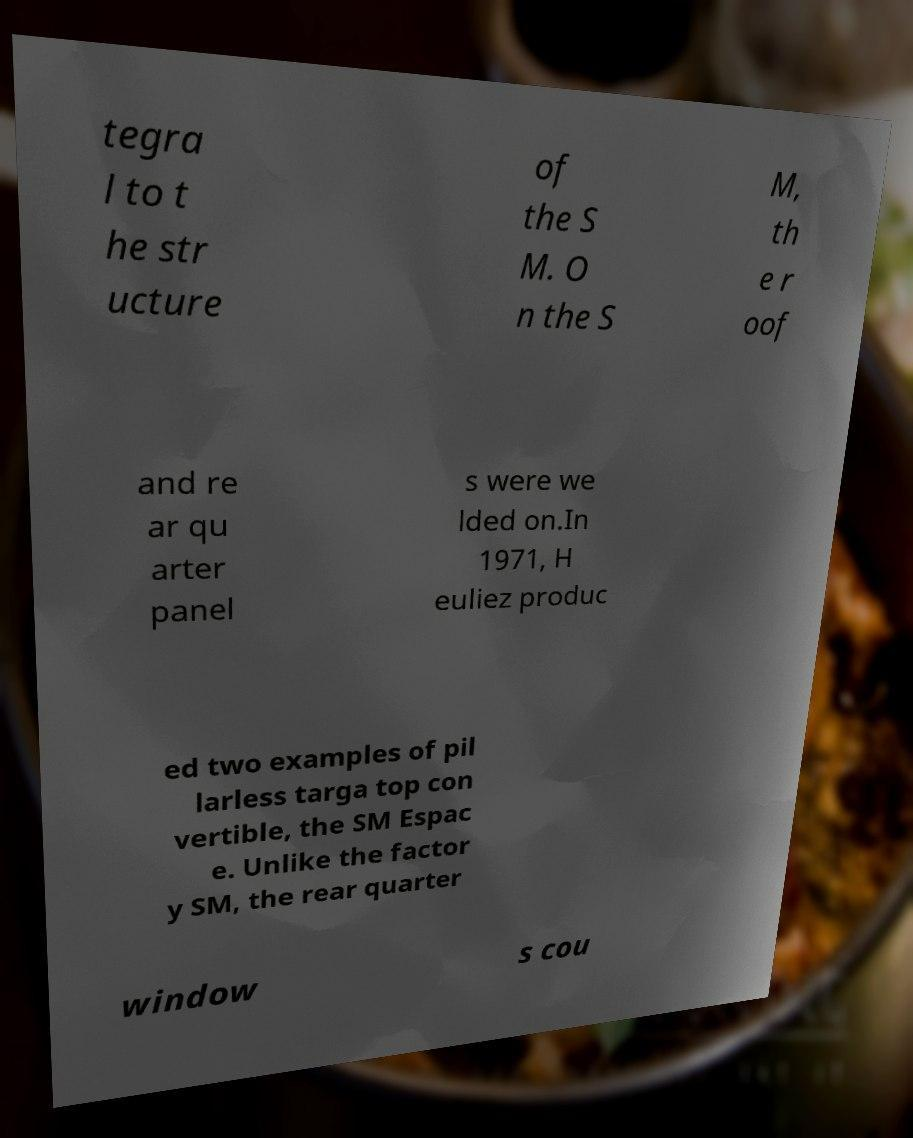Please read and relay the text visible in this image. What does it say? tegra l to t he str ucture of the S M. O n the S M, th e r oof and re ar qu arter panel s were we lded on.In 1971, H euliez produc ed two examples of pil larless targa top con vertible, the SM Espac e. Unlike the factor y SM, the rear quarter window s cou 